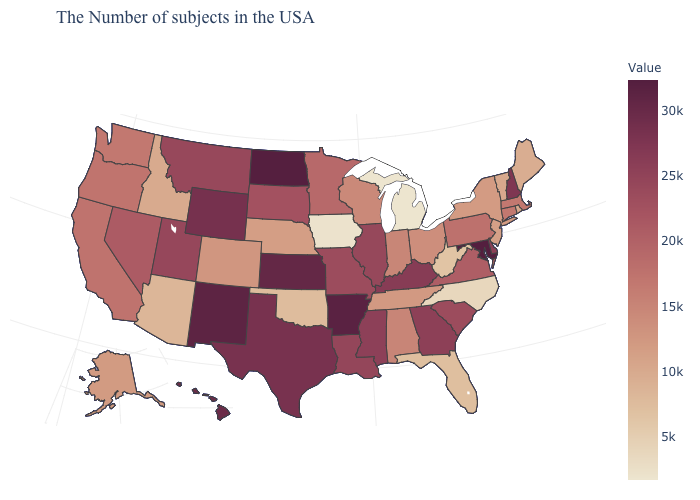Is the legend a continuous bar?
Keep it brief. Yes. Among the states that border Nebraska , which have the highest value?
Be succinct. Kansas. Which states hav the highest value in the West?
Answer briefly. New Mexico. Which states have the highest value in the USA?
Quick response, please. Maryland. Which states hav the highest value in the South?
Answer briefly. Maryland. Does Kansas have the lowest value in the MidWest?
Keep it brief. No. 